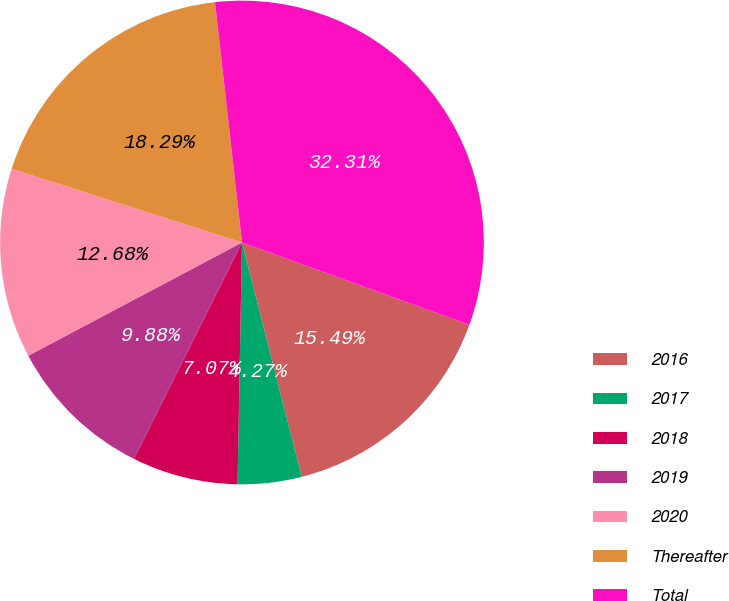Convert chart. <chart><loc_0><loc_0><loc_500><loc_500><pie_chart><fcel>2016<fcel>2017<fcel>2018<fcel>2019<fcel>2020<fcel>Thereafter<fcel>Total<nl><fcel>15.49%<fcel>4.27%<fcel>7.07%<fcel>9.88%<fcel>12.68%<fcel>18.29%<fcel>32.31%<nl></chart> 